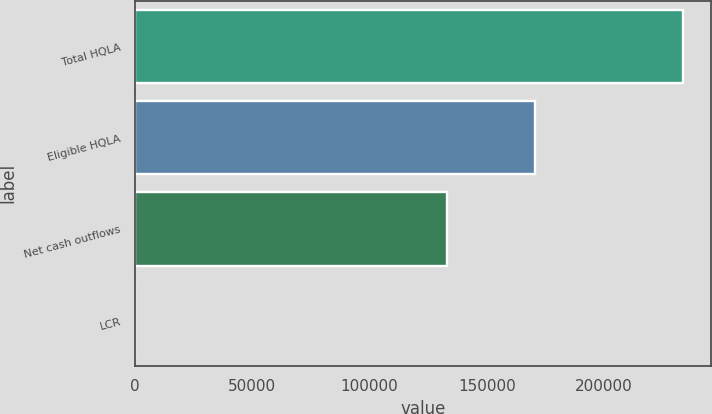Convert chart. <chart><loc_0><loc_0><loc_500><loc_500><bar_chart><fcel>Total HQLA<fcel>Eligible HQLA<fcel>Net cash outflows<fcel>LCR<nl><fcel>233721<fcel>170621<fcel>133126<fcel>128<nl></chart> 